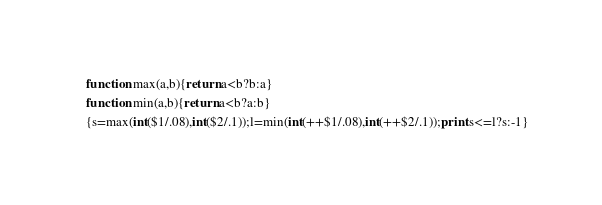Convert code to text. <code><loc_0><loc_0><loc_500><loc_500><_Awk_>function max(a,b){return a<b?b:a}
function min(a,b){return a<b?a:b}
{s=max(int($1/.08),int($2/.1));l=min(int(++$1/.08),int(++$2/.1));print s<=l?s:-1}</code> 